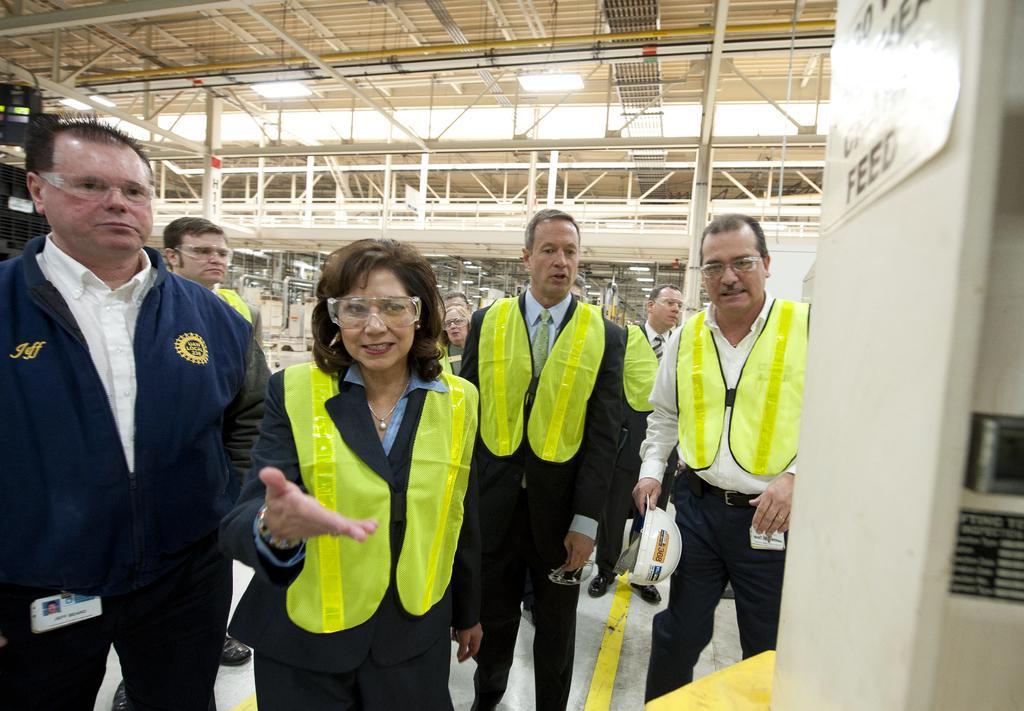Please provide a concise description of this image. In this image I can see group of people standing. There are name boards, there is ceiling with lights and iron frames. Also there are poles and some other objects. 